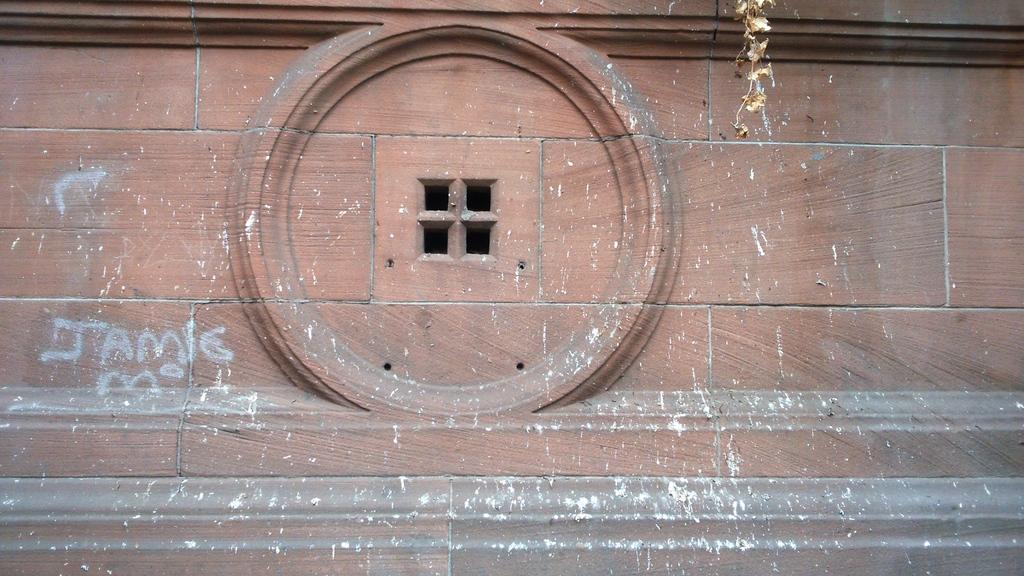Could you give a brief overview of what you see in this image? This is a picture of a building, where there are some letters written on the building, and there is a kind of window. 